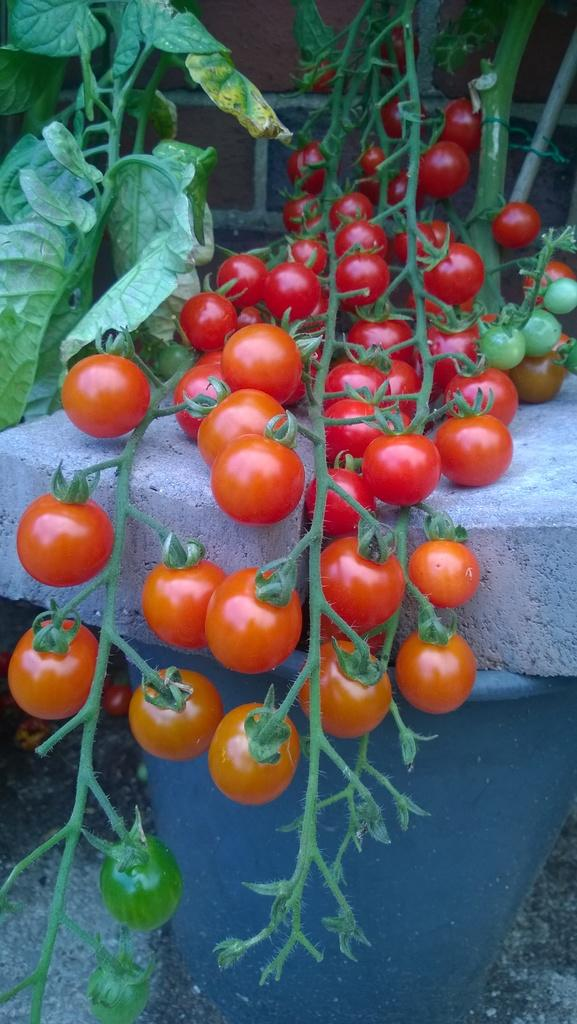What type of living organisms can be seen in the image? Plants can be seen in the image. What is growing on the plants? There are tomatoes on the plants. What is the pot used for in the image? The pot is likely used to hold the plants. What material are the bricks made of in the image? The bricks in the image are made of a solid material, likely clay or concrete. What type of soup is being served in the image? There is no soup present in the image; it features plants with tomatoes, a pot, and bricks. 